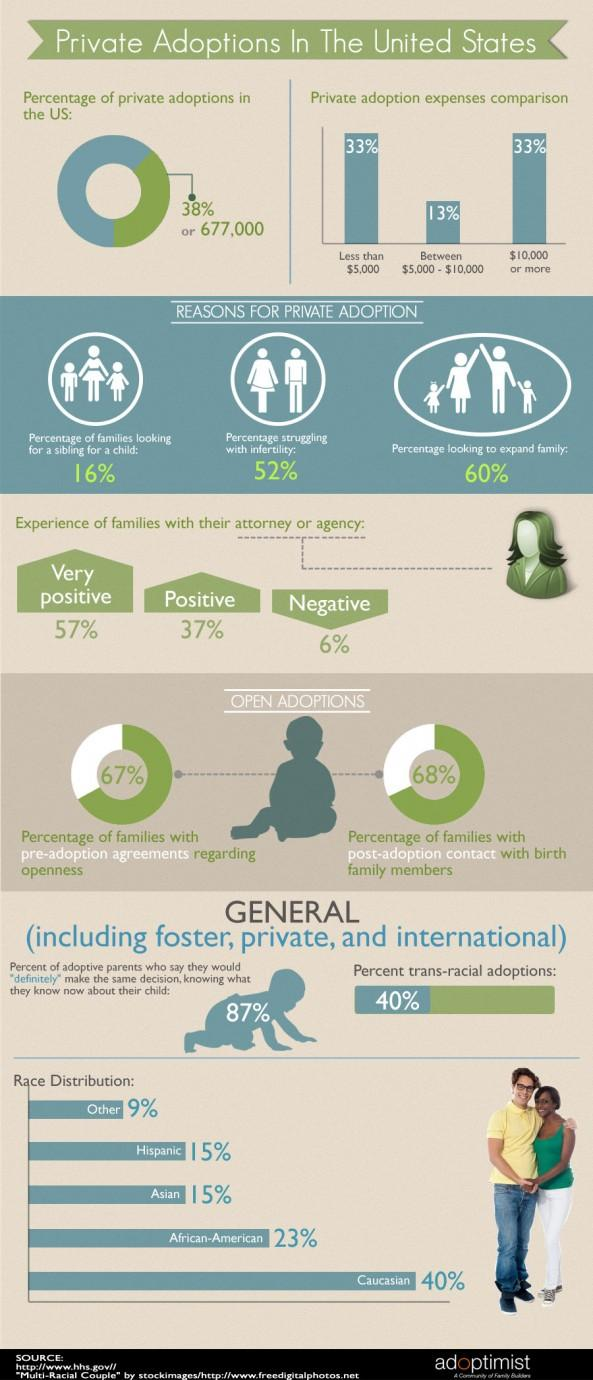Outline some significant characteristics in this image. According to a recent survey, approximately 40% of couples in the United States are not looking to expand their family. According to recent data, approximately 38% of adoptions in the United States are private. According to a recent study, it was found that 52% of couples in the United States are struggling with infertility. 